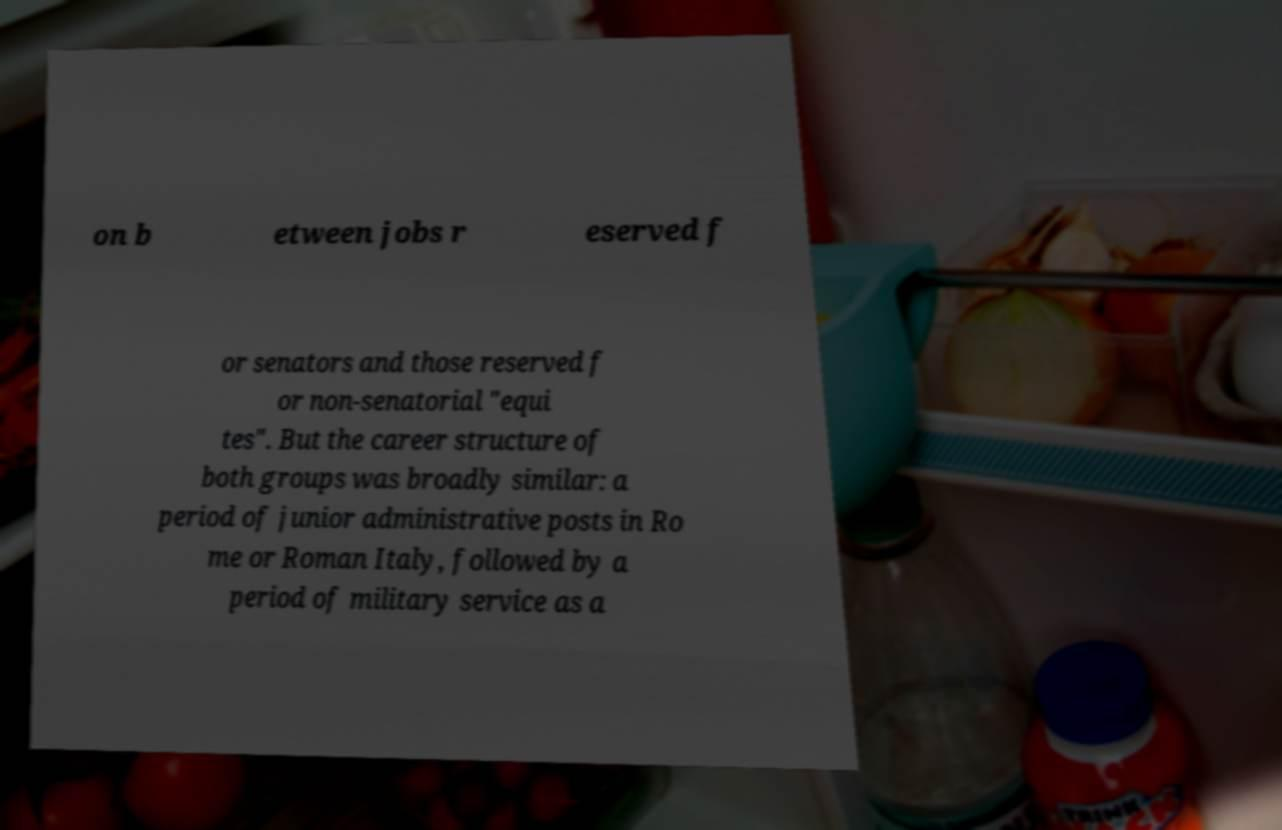Please identify and transcribe the text found in this image. on b etween jobs r eserved f or senators and those reserved f or non-senatorial "equi tes". But the career structure of both groups was broadly similar: a period of junior administrative posts in Ro me or Roman Italy, followed by a period of military service as a 